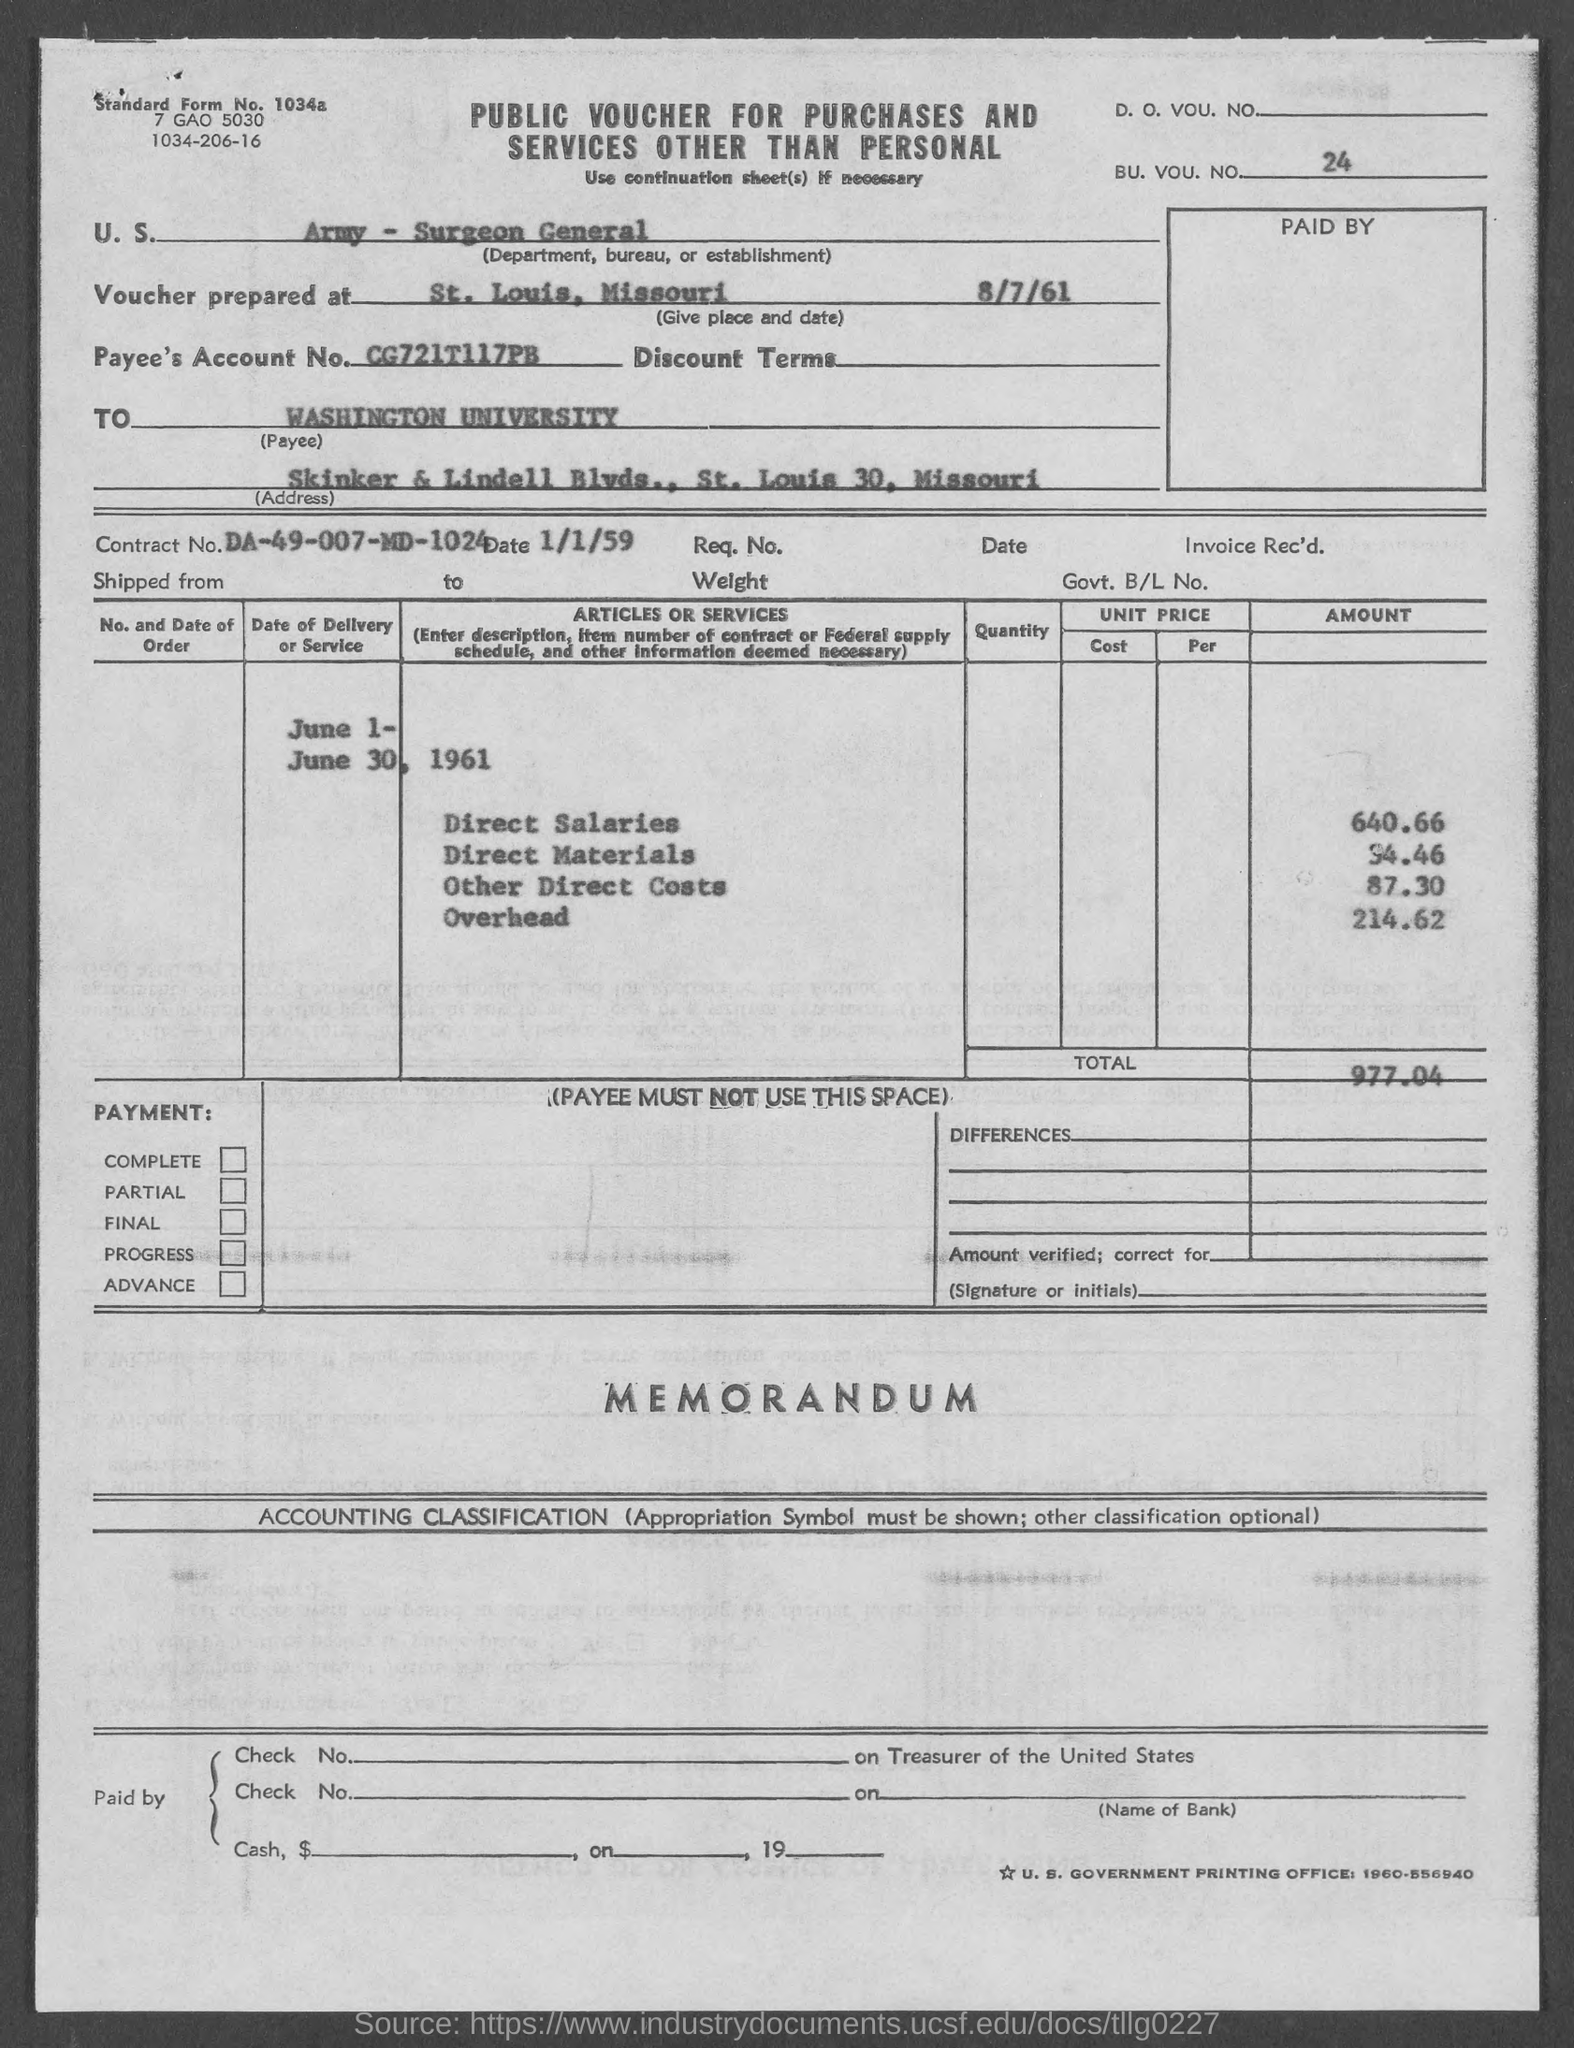What type of voucher is given here?
Keep it short and to the point. PUBLIC VOUCHER FOR PURCHASES AND SERVICES OTHER THAN PERSONAL. What is the BU. VOU. NO. mentioned in the voucher?
Offer a terse response. 24. What is the U.S. Department, Bureau, or Establishment given in the voucher?
Give a very brief answer. Army - Surgeon General. What is the place & date of voucher prepared?
Make the answer very short. St. Louis, Missouri    8/7/61. What is the Payee's Account No. given in the voucher?
Provide a succinct answer. CG721T117PB. What is the Contract No. given in the voucher?
Provide a succinct answer. DA-49-007-MD-1024. What is the date of contract given in the voucher?
Keep it short and to the point. 1/1/59. What is the direct salaries cost mentioned in the voucher?
Provide a succinct answer. 640.66. What is the overhead cost mentioned in the voucher?
Offer a terse response. 214.62. What is the total voucher amount mentioned in the document?
Provide a short and direct response. 977.04. 